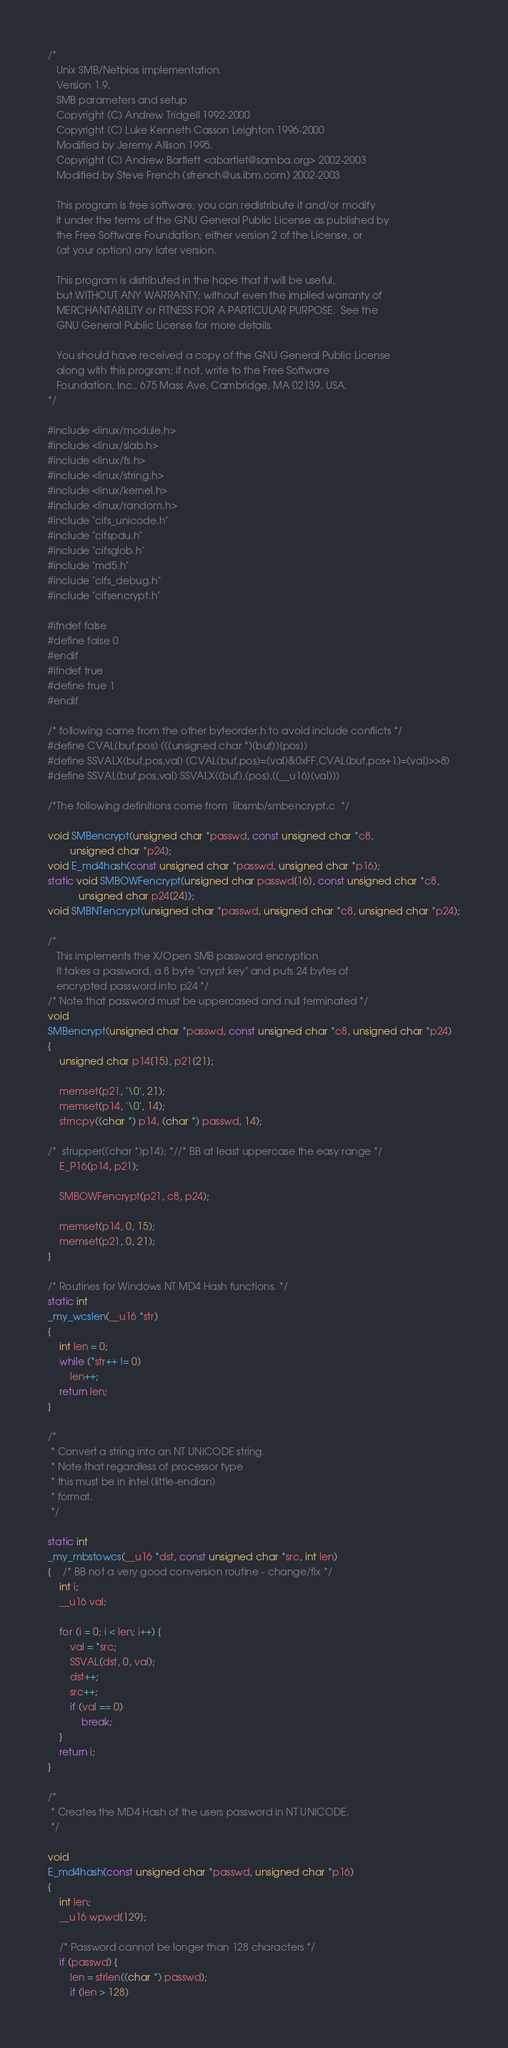<code> <loc_0><loc_0><loc_500><loc_500><_C_>/*
   Unix SMB/Netbios implementation.
   Version 1.9.
   SMB parameters and setup
   Copyright (C) Andrew Tridgell 1992-2000
   Copyright (C) Luke Kenneth Casson Leighton 1996-2000
   Modified by Jeremy Allison 1995.
   Copyright (C) Andrew Bartlett <abartlet@samba.org> 2002-2003
   Modified by Steve French (sfrench@us.ibm.com) 2002-2003

   This program is free software; you can redistribute it and/or modify
   it under the terms of the GNU General Public License as published by
   the Free Software Foundation; either version 2 of the License, or
   (at your option) any later version.

   This program is distributed in the hope that it will be useful,
   but WITHOUT ANY WARRANTY; without even the implied warranty of
   MERCHANTABILITY or FITNESS FOR A PARTICULAR PURPOSE.  See the
   GNU General Public License for more details.

   You should have received a copy of the GNU General Public License
   along with this program; if not, write to the Free Software
   Foundation, Inc., 675 Mass Ave, Cambridge, MA 02139, USA.
*/

#include <linux/module.h>
#include <linux/slab.h>
#include <linux/fs.h>
#include <linux/string.h>
#include <linux/kernel.h>
#include <linux/random.h>
#include "cifs_unicode.h"
#include "cifspdu.h"
#include "cifsglob.h"
#include "md5.h"
#include "cifs_debug.h"
#include "cifsencrypt.h"

#ifndef false
#define false 0
#endif
#ifndef true
#define true 1
#endif

/* following came from the other byteorder.h to avoid include conflicts */
#define CVAL(buf,pos) (((unsigned char *)(buf))[pos])
#define SSVALX(buf,pos,val) (CVAL(buf,pos)=(val)&0xFF,CVAL(buf,pos+1)=(val)>>8)
#define SSVAL(buf,pos,val) SSVALX((buf),(pos),((__u16)(val)))

/*The following definitions come from  libsmb/smbencrypt.c  */

void SMBencrypt(unsigned char *passwd, const unsigned char *c8,
		unsigned char *p24);
void E_md4hash(const unsigned char *passwd, unsigned char *p16);
static void SMBOWFencrypt(unsigned char passwd[16], const unsigned char *c8,
		   unsigned char p24[24]);
void SMBNTencrypt(unsigned char *passwd, unsigned char *c8, unsigned char *p24);

/*
   This implements the X/Open SMB password encryption
   It takes a password, a 8 byte "crypt key" and puts 24 bytes of
   encrypted password into p24 */
/* Note that password must be uppercased and null terminated */
void
SMBencrypt(unsigned char *passwd, const unsigned char *c8, unsigned char *p24)
{
	unsigned char p14[15], p21[21];

	memset(p21, '\0', 21);
	memset(p14, '\0', 14);
	strncpy((char *) p14, (char *) passwd, 14);

/*	strupper((char *)p14); *//* BB at least uppercase the easy range */
	E_P16(p14, p21);

	SMBOWFencrypt(p21, c8, p24);

	memset(p14, 0, 15);
	memset(p21, 0, 21);
}

/* Routines for Windows NT MD4 Hash functions. */
static int
_my_wcslen(__u16 *str)
{
	int len = 0;
	while (*str++ != 0)
		len++;
	return len;
}

/*
 * Convert a string into an NT UNICODE string.
 * Note that regardless of processor type
 * this must be in intel (little-endian)
 * format.
 */

static int
_my_mbstowcs(__u16 *dst, const unsigned char *src, int len)
{	/* BB not a very good conversion routine - change/fix */
	int i;
	__u16 val;

	for (i = 0; i < len; i++) {
		val = *src;
		SSVAL(dst, 0, val);
		dst++;
		src++;
		if (val == 0)
			break;
	}
	return i;
}

/*
 * Creates the MD4 Hash of the users password in NT UNICODE.
 */

void
E_md4hash(const unsigned char *passwd, unsigned char *p16)
{
	int len;
	__u16 wpwd[129];

	/* Password cannot be longer than 128 characters */
	if (passwd) {
		len = strlen((char *) passwd);
		if (len > 128)</code> 